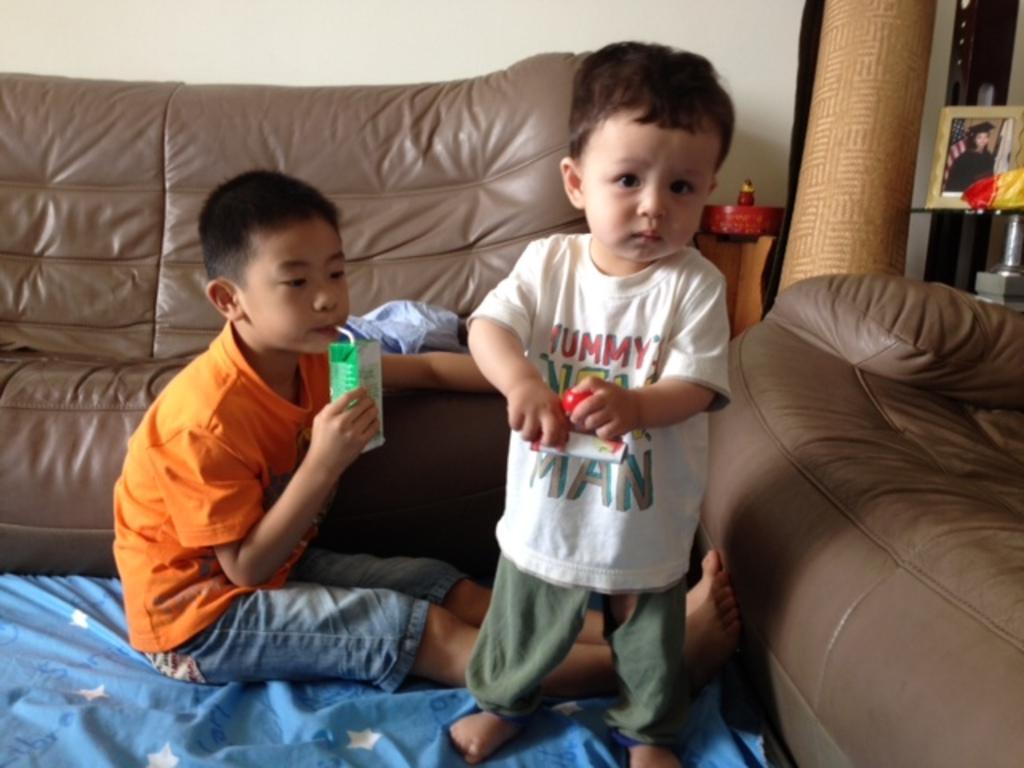How would you summarize this image in a sentence or two? Here in this picture we can see a child standing and another child sitting on the floor and we can see the child on the left side is drinking something and we can also see a sofa and a chair present on the floor and on the right side we can see a photo frame present on a table. 